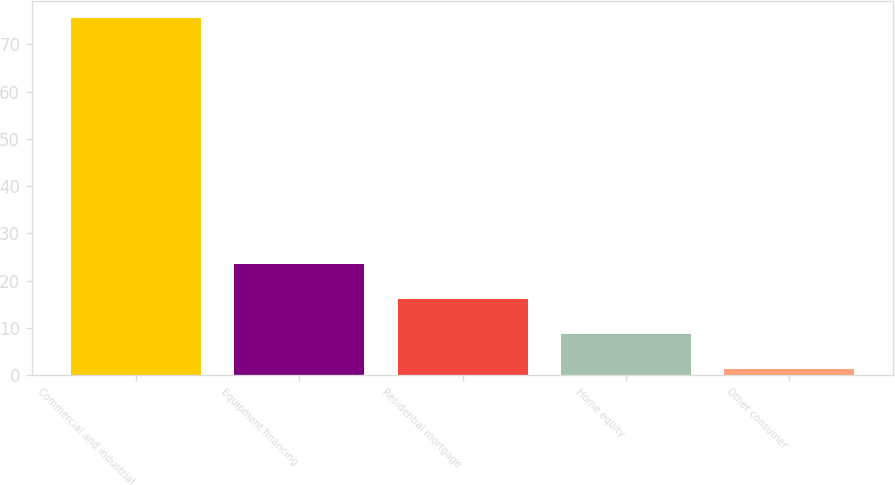Convert chart to OTSL. <chart><loc_0><loc_0><loc_500><loc_500><bar_chart><fcel>Commercial and industrial<fcel>Equipment financing<fcel>Residential mortgage<fcel>Home equity<fcel>Other consumer<nl><fcel>75.5<fcel>23.56<fcel>16.14<fcel>8.72<fcel>1.3<nl></chart> 